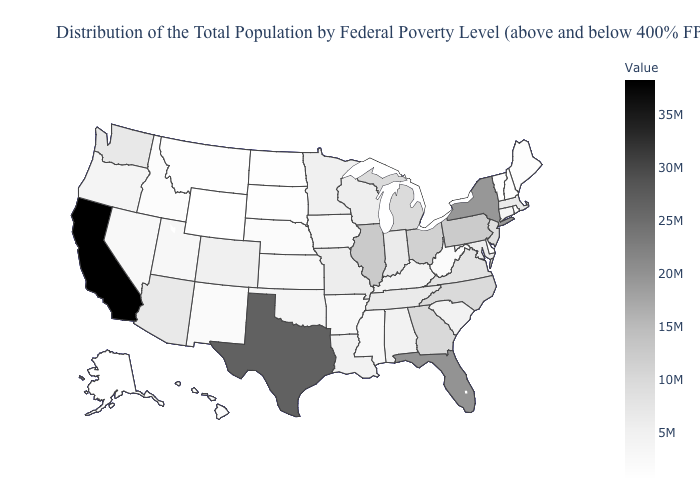Among the states that border Oregon , which have the lowest value?
Be succinct. Idaho. Does Texas have the highest value in the South?
Keep it brief. Yes. Among the states that border Nebraska , does Iowa have the lowest value?
Write a very short answer. No. Which states have the lowest value in the USA?
Write a very short answer. Wyoming. Which states have the lowest value in the South?
Short answer required. Delaware. 